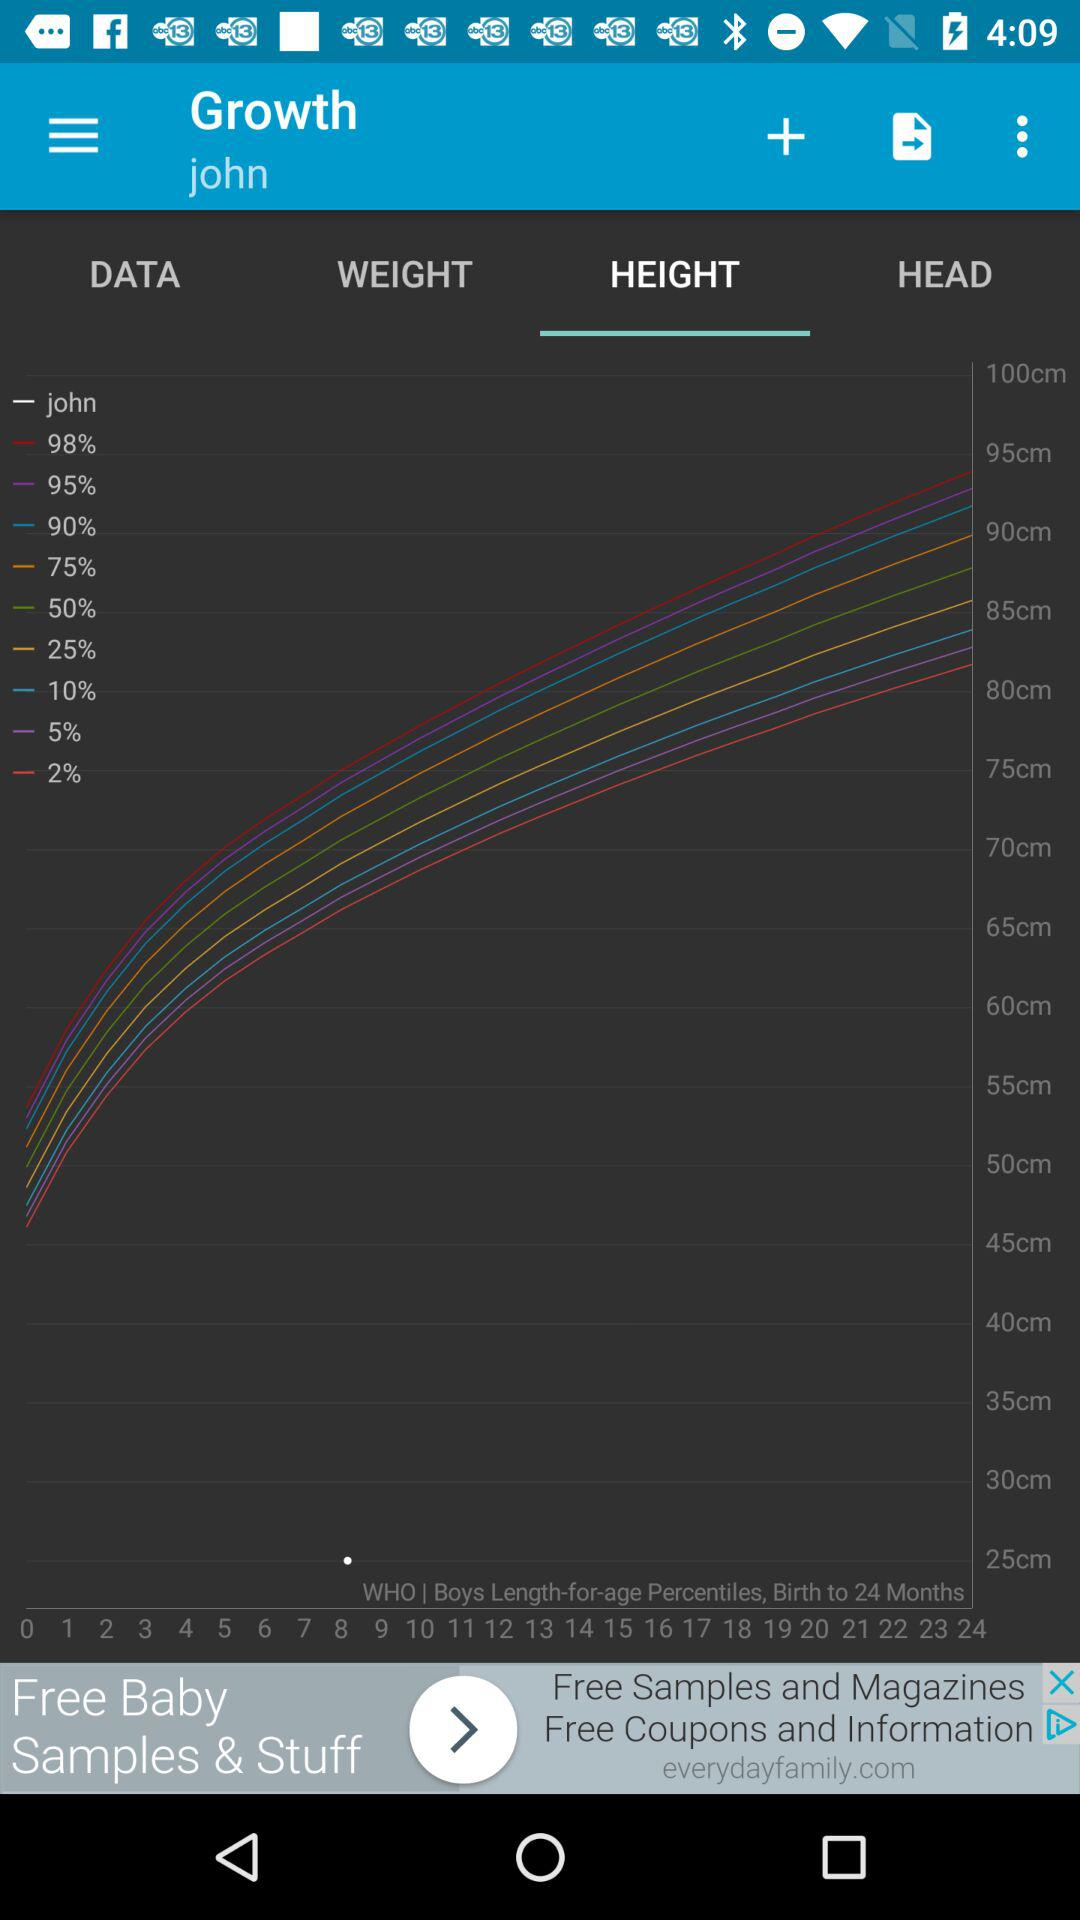Which tab has been selected? The selected tab is "HEIGHT". 